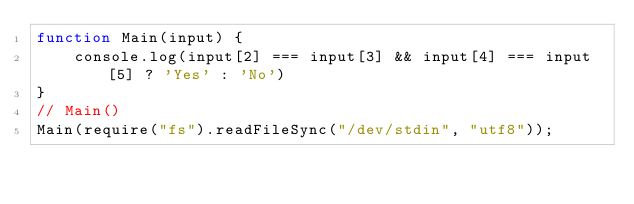Convert code to text. <code><loc_0><loc_0><loc_500><loc_500><_JavaScript_>function Main(input) {
    console.log(input[2] === input[3] && input[4] === input[5] ? 'Yes' : 'No')
}
// Main()
Main(require("fs").readFileSync("/dev/stdin", "utf8"));
</code> 